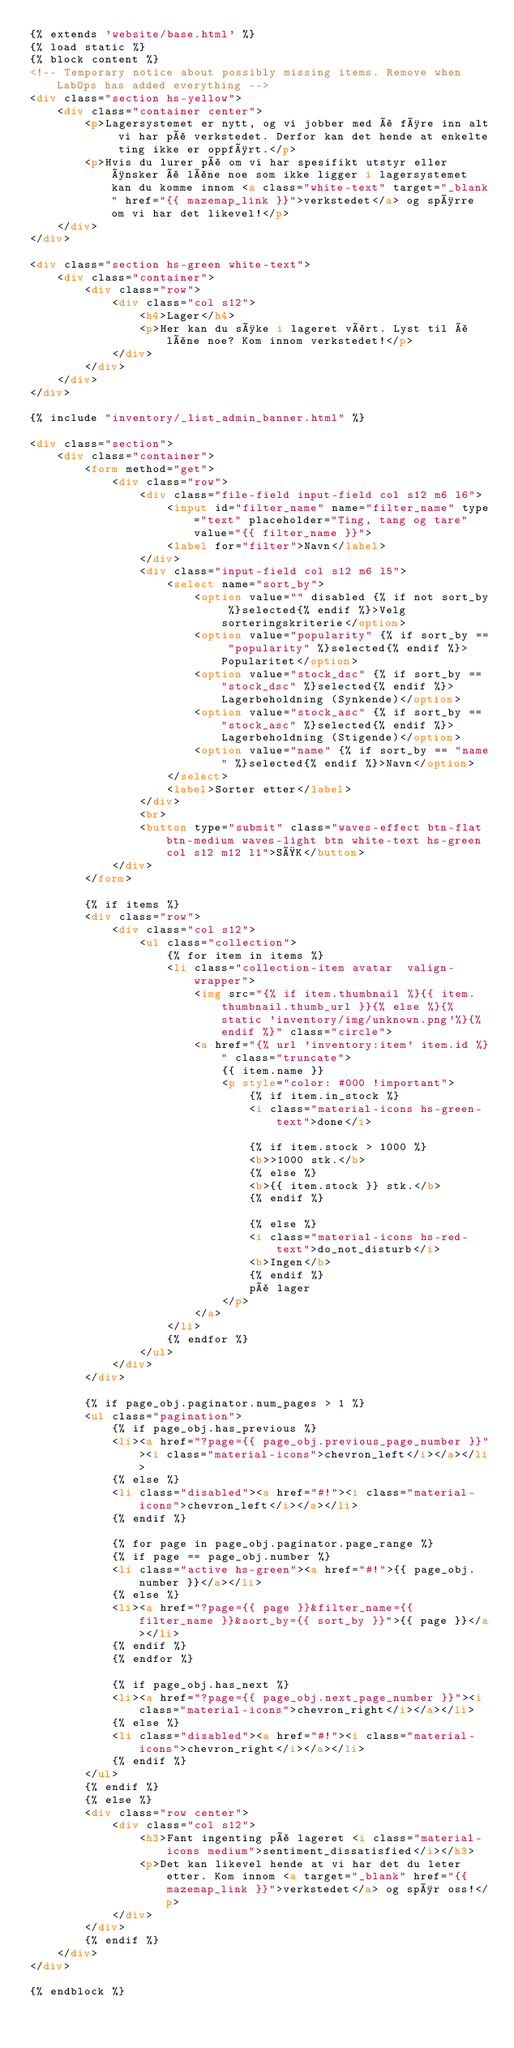Convert code to text. <code><loc_0><loc_0><loc_500><loc_500><_HTML_>{% extends 'website/base.html' %}
{% load static %}
{% block content %}
<!-- Temporary notice about possibly missing items. Remove when LabOps has added everything -->
<div class="section hs-yellow">
    <div class="container center">
        <p>Lagersystemet er nytt, og vi jobber med å føre inn alt vi har på verkstedet. Derfor kan det hende at enkelte ting ikke er oppført.</p>
        <p>Hvis du lurer på om vi har spesifikt utstyr eller ønsker å låne noe som ikke ligger i lagersystemet kan du komme innom <a class="white-text" target="_blank" href="{{ mazemap_link }}">verkstedet</a> og spørre om vi har det likevel!</p>
    </div>
</div>

<div class="section hs-green white-text">
    <div class="container">
        <div class="row">
            <div class="col s12">
                <h4>Lager</h4>
                <p>Her kan du søke i lageret vårt. Lyst til å låne noe? Kom innom verkstedet!</p>
            </div>
        </div>
    </div>
</div>

{% include "inventory/_list_admin_banner.html" %}

<div class="section">
    <div class="container">
		<form method="get">
            <div class="row">
			    <div class="file-field input-field col s12 m6 l6">
                    <input id="filter_name" name="filter_name" type="text" placeholder="Ting, tang og tare" value="{{ filter_name }}">
                    <label for="filter">Navn</label>
                </div>
                <div class="input-field col s12 m6 l5">
                    <select name="sort_by">
                        <option value="" disabled {% if not sort_by %}selected{% endif %}>Velg sorteringskriterie</option>
                        <option value="popularity" {% if sort_by == "popularity" %}selected{% endif %}>Popularitet</option>
                        <option value="stock_dsc" {% if sort_by == "stock_dsc" %}selected{% endif %}>Lagerbeholdning (Synkende)</option>
                        <option value="stock_asc" {% if sort_by == "stock_asc" %}selected{% endif %}>Lagerbeholdning (Stigende)</option>
                        <option value="name" {% if sort_by == "name" %}selected{% endif %}>Navn</option>
                    </select>
                    <label>Sorter etter</label>
                </div>
                <br>
                <button type="submit" class="waves-effect btn-flat btn-medium waves-light btn white-text hs-green col s12 m12 l1">SØK</button>
			</div>
		</form>

        {% if items %}
        <div class="row">
            <div class="col s12">
                <ul class="collection">
                    {% for item in items %}
                    <li class="collection-item avatar  valign-wrapper">
                        <img src="{% if item.thumbnail %}{{ item.thumbnail.thumb_url }}{% else %}{% static 'inventory/img/unknown.png'%}{% endif %}" class="circle">
                        <a href="{% url 'inventory:item' item.id %}" class="truncate">
                            {{ item.name }}
                            <p style="color: #000 !important">
                                {% if item.in_stock %}
                                <i class="material-icons hs-green-text">done</i>

                                {% if item.stock > 1000 %}
                                <b>>1000 stk.</b>
                                {% else %}
                                <b>{{ item.stock }} stk.</b>
                                {% endif %}

                                {% else %}
                                <i class="material-icons hs-red-text">do_not_disturb</i>
                                <b>Ingen</b>
                                {% endif %}
                                på lager
                            </p>
                        </a>
                    </li>
                    {% endfor %}
                </ul>
            </div>
        </div>

        {% if page_obj.paginator.num_pages > 1 %}
        <ul class="pagination">
            {% if page_obj.has_previous %}
            <li><a href="?page={{ page_obj.previous_page_number }}"><i class="material-icons">chevron_left</i></a></li>
            {% else %}
            <li class="disabled"><a href="#!"><i class="material-icons">chevron_left</i></a></li>
            {% endif %}

            {% for page in page_obj.paginator.page_range %}
            {% if page == page_obj.number %}
            <li class="active hs-green"><a href="#!">{{ page_obj.number }}</a></li>
            {% else %}
            <li><a href="?page={{ page }}&filter_name={{ filter_name }}&sort_by={{ sort_by }}">{{ page }}</a></li>
            {% endif %}
            {% endfor %}

            {% if page_obj.has_next %}
            <li><a href="?page={{ page_obj.next_page_number }}"><i class="material-icons">chevron_right</i></a></li>
            {% else %}
            <li class="disabled"><a href="#!"><i class="material-icons">chevron_right</i></a></li>
            {% endif %}
        </ul>
        {% endif %}
        {% else %}
        <div class="row center">
            <div class="col s12">
                <h3>Fant ingenting på lageret <i class="material-icons medium">sentiment_dissatisfied</i></h3>
                <p>Det kan likevel hende at vi har det du leter etter. Kom innom <a target="_blank" href="{{ mazemap_link }}">verkstedet</a> og spør oss!</p>
            </div>
        </div>
        {% endif %}
    </div>
</div>

{% endblock %}
</code> 